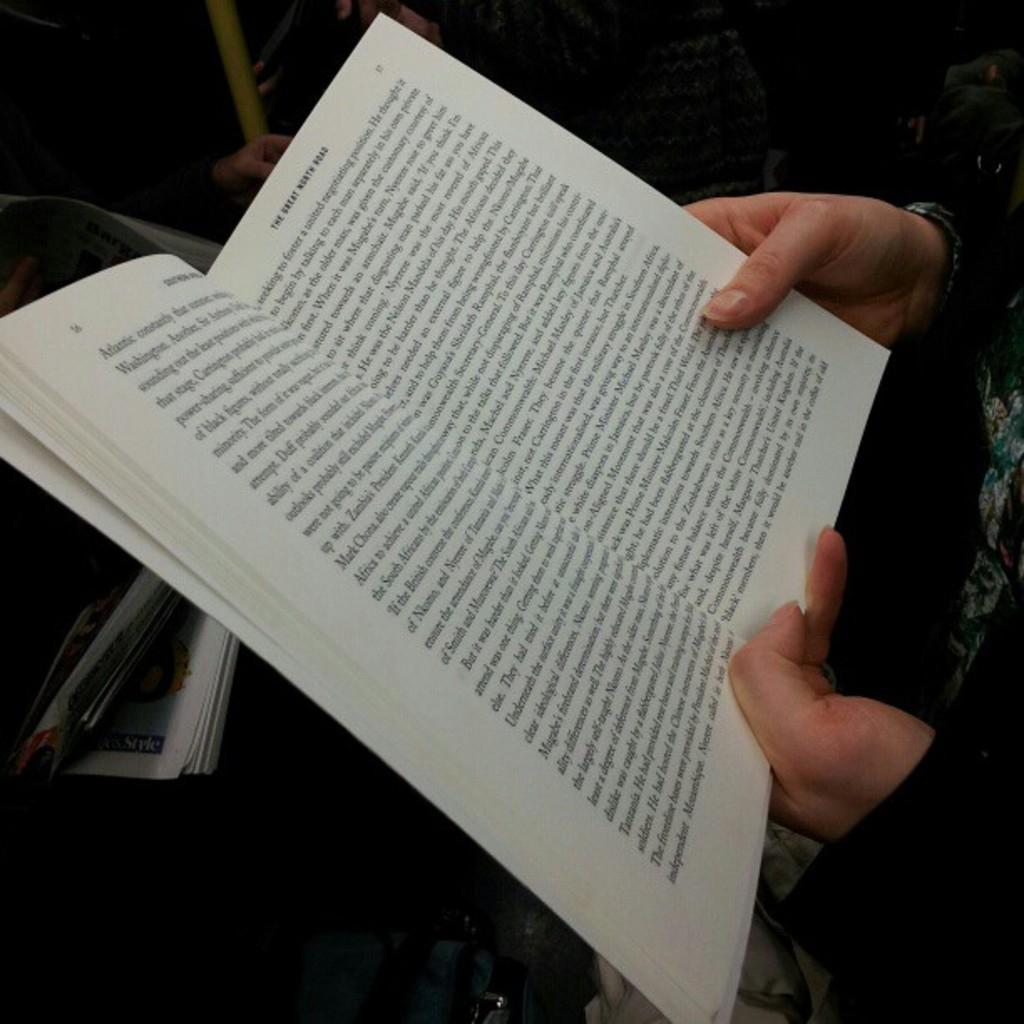How would you summarize this image in a sentence or two? In this image I can see a person holding a book. Some matter is written in the book. 